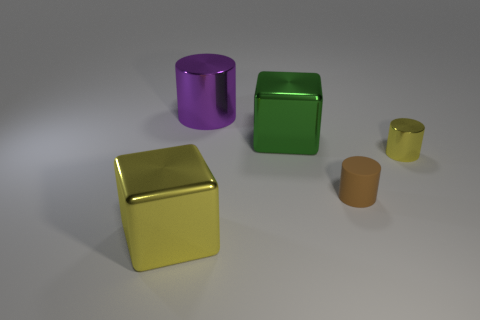What is the material of the large thing that is the same color as the tiny shiny object?
Give a very brief answer. Metal. How many other things are the same material as the yellow cylinder?
Make the answer very short. 3. What material is the other cube that is the same size as the yellow block?
Provide a short and direct response. Metal. What number of gray objects are cylinders or rubber things?
Keep it short and to the point. 0. What color is the cylinder that is behind the matte object and on the right side of the large purple metallic object?
Offer a terse response. Yellow. Is the cube that is to the right of the purple metallic thing made of the same material as the yellow object that is behind the large yellow shiny cube?
Provide a succinct answer. Yes. Is the number of large purple metallic cylinders that are left of the large purple metallic thing greater than the number of brown rubber things on the left side of the large yellow metallic thing?
Make the answer very short. No. There is another shiny thing that is the same size as the brown object; what is its shape?
Offer a terse response. Cylinder. What number of things are either small shiny objects or yellow objects that are behind the tiny rubber cylinder?
Give a very brief answer. 1. Is the color of the small rubber object the same as the tiny metallic object?
Offer a terse response. No. 